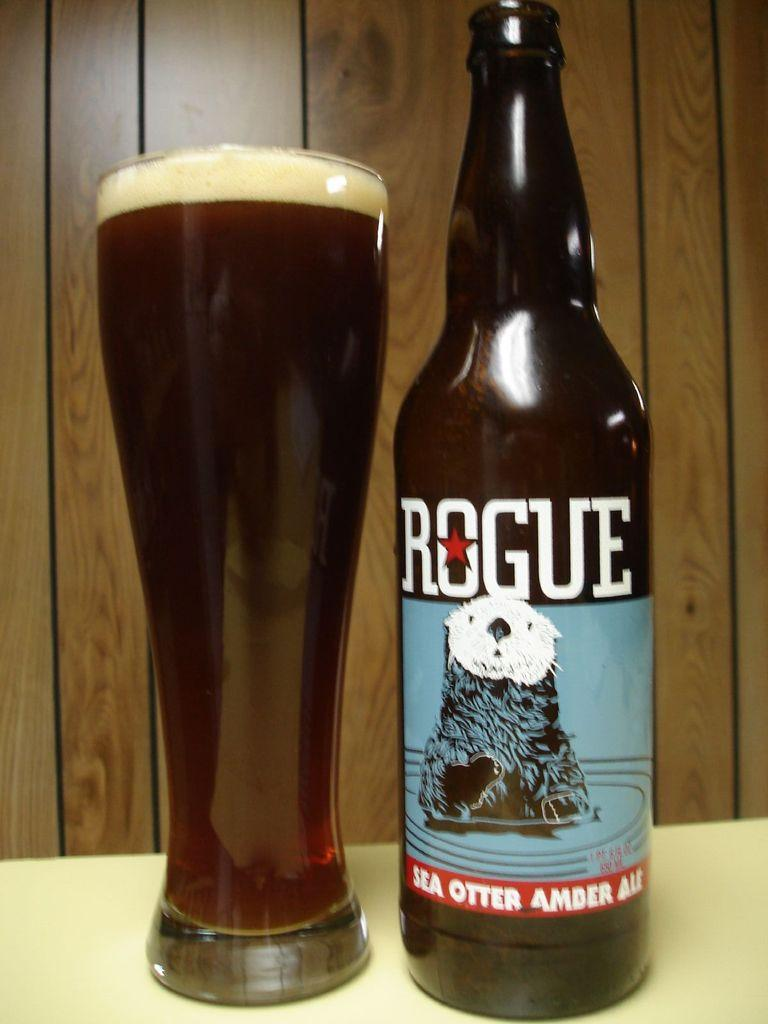<image>
Create a compact narrative representing the image presented. A rogue beer beverage poured in a glass with an otter as their logo 